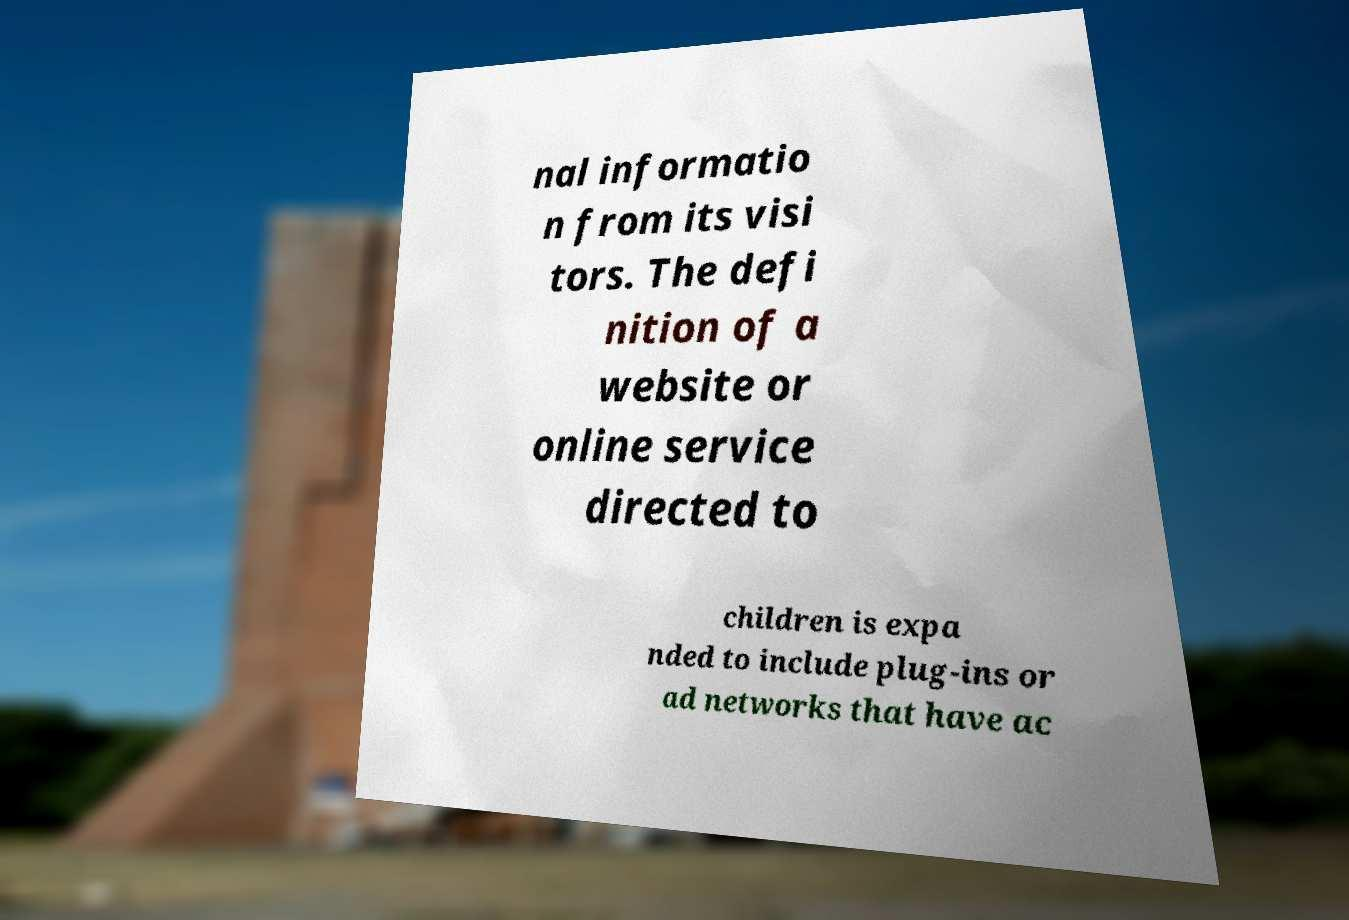Could you extract and type out the text from this image? nal informatio n from its visi tors. The defi nition of a website or online service directed to children is expa nded to include plug-ins or ad networks that have ac 